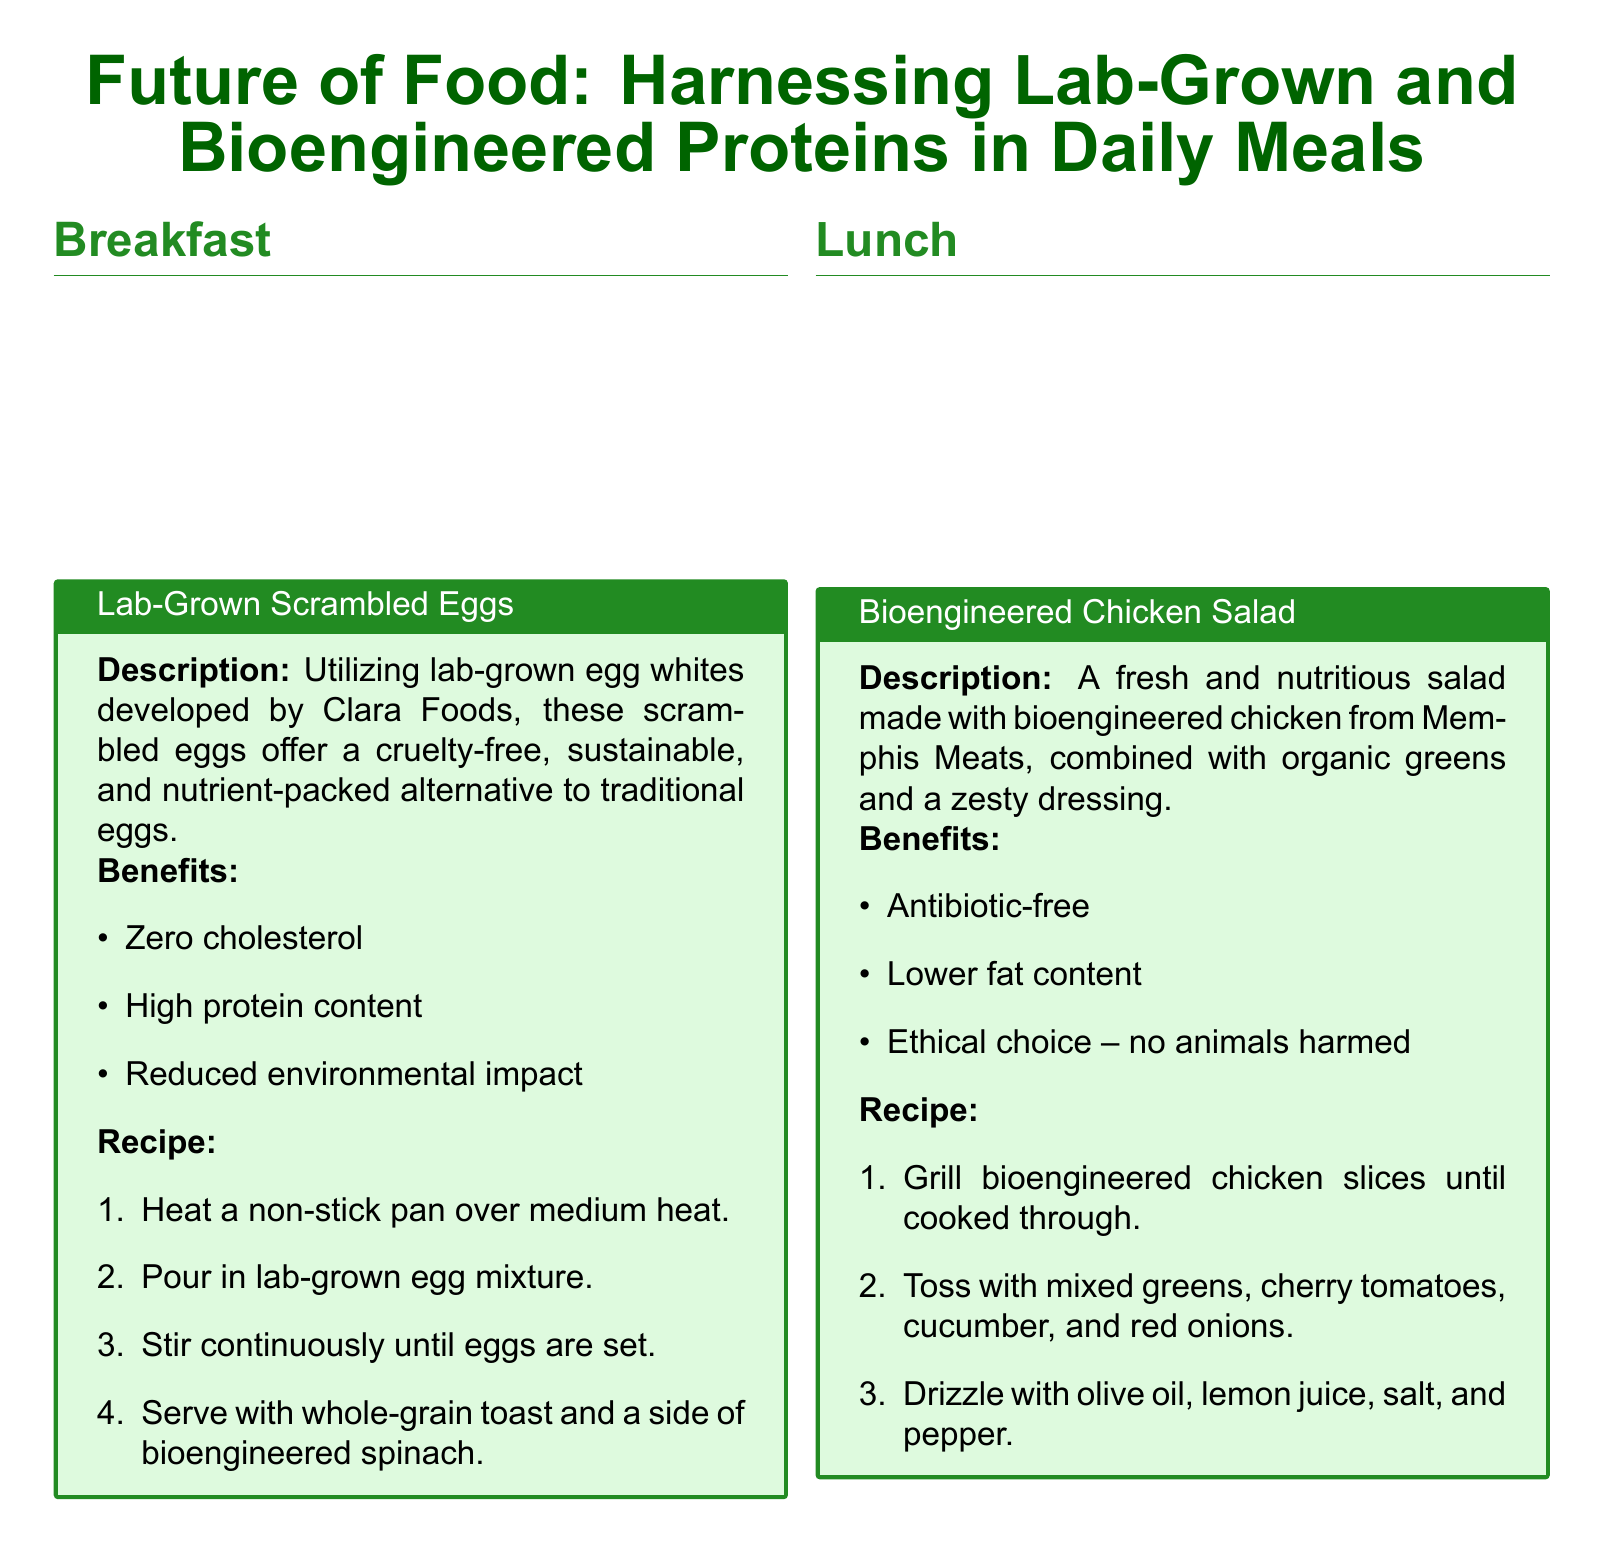What is the title of the document? The title is presented at the beginning of the document, indicating the focus on food innovations.
Answer: Future of Food: Harnessing Lab-Grown and Bioengineered Proteins in Daily Meals Which startup developed lab-grown egg whites? The document specifies the name of the company that produced the lab-grown egg whites used in the breakfast item.
Answer: Clara Foods What type of protein is used in the chicken salad? The document indicates the type of chicken used in the lunch recipe, highlighting its innovative aspect.
Answer: Bioengineered chicken What is a key benefit of the lab-grown beef burger? This information is found in the benefits section of the dinner meal item, showcasing its environmental impact.
Answer: Reduced greenhouse gas emissions How is the ice cream described in the meal plan? This question refers to the characteristics of the dessert item elaborated in the document.
Answer: Creamy and delicious What meal includes whole-grain toast? The document describes each meal and its components, revealing the specific meal that features whole-grain toast.
Answer: Breakfast Which ingredient is not used in the bioengineered chicken salad? This question covers the components of the salad recipe to illustrate its healthy attributes.
Answer: Antibiotics How many steps are in the recipe for lab-grown scrambled eggs? The answer can be found in the recipe section, providing clarity on the preparation process.
Answer: Four steps What is a benefit of bioengineered dairy ice cream? This question focuses on the advantages mentioned in the dessert section of the document.
Answer: Lactose-free 